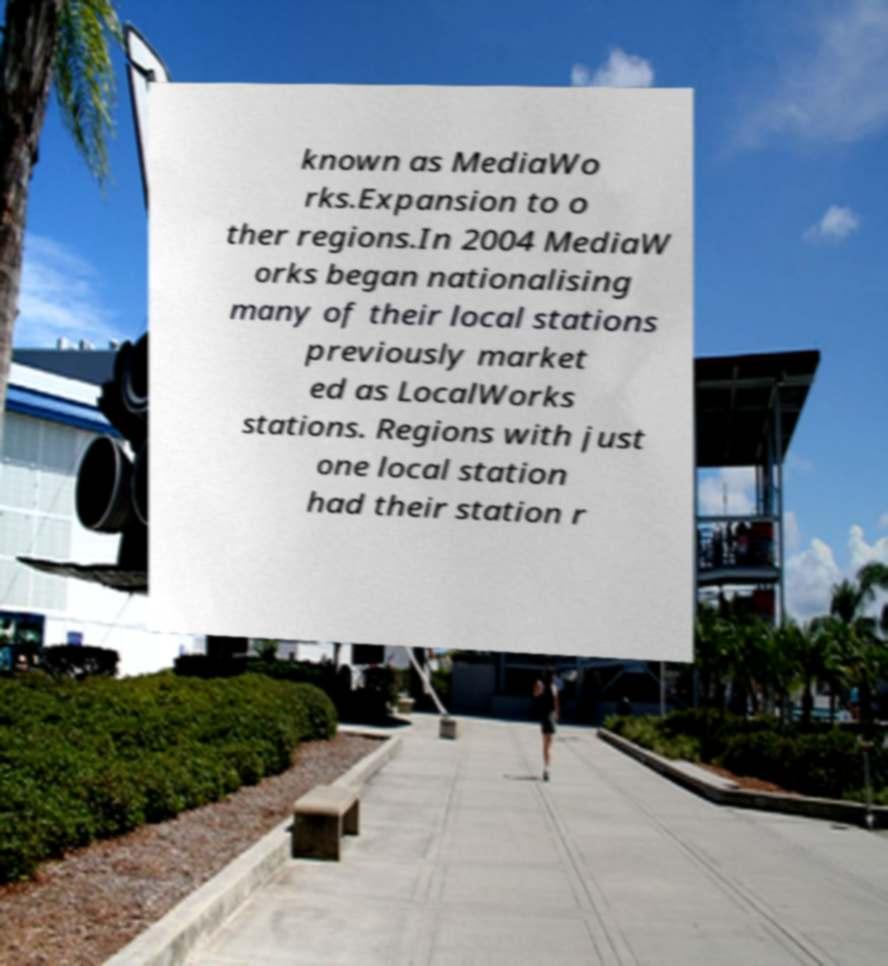Can you accurately transcribe the text from the provided image for me? known as MediaWo rks.Expansion to o ther regions.In 2004 MediaW orks began nationalising many of their local stations previously market ed as LocalWorks stations. Regions with just one local station had their station r 